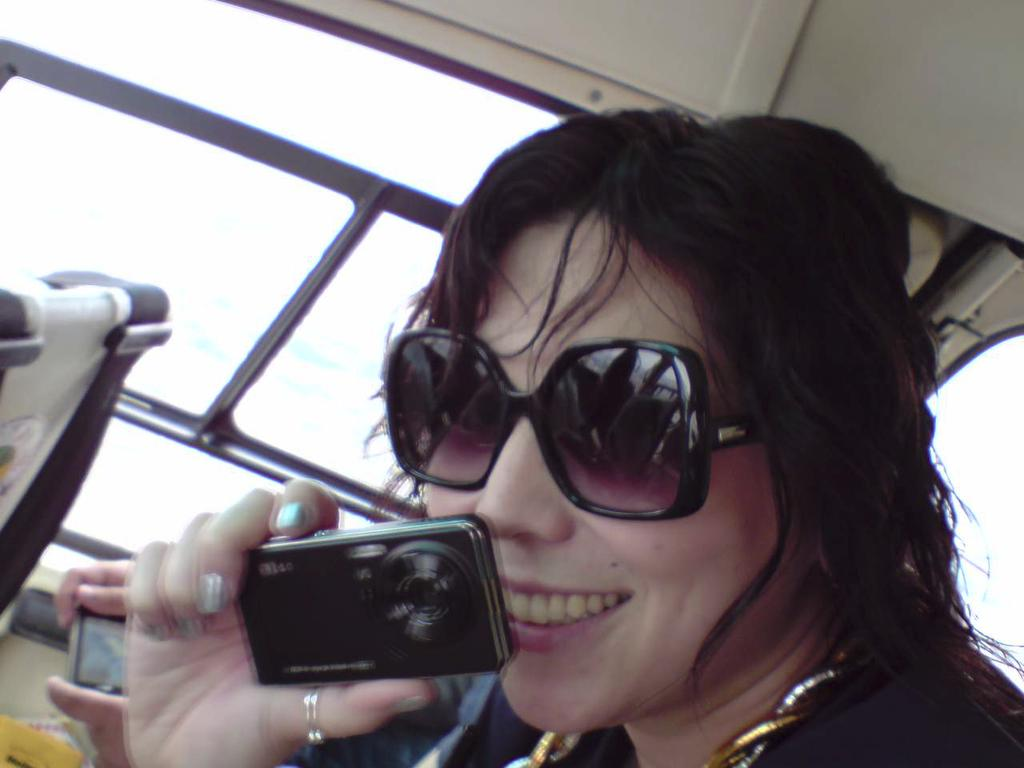Who is the main subject in the image? There is a woman in the image. What is the woman doing in the image? The woman is standing in the image. What is the woman holding in her hand? The woman is holding a camera in her hand. What type of accessory is the woman wearing? The woman is wearing black color goggles. Can you see any smoke coming from the woman's camera in the image? There is no smoke visible in the image, and the woman is not using her camera in a way that would produce smoke. 